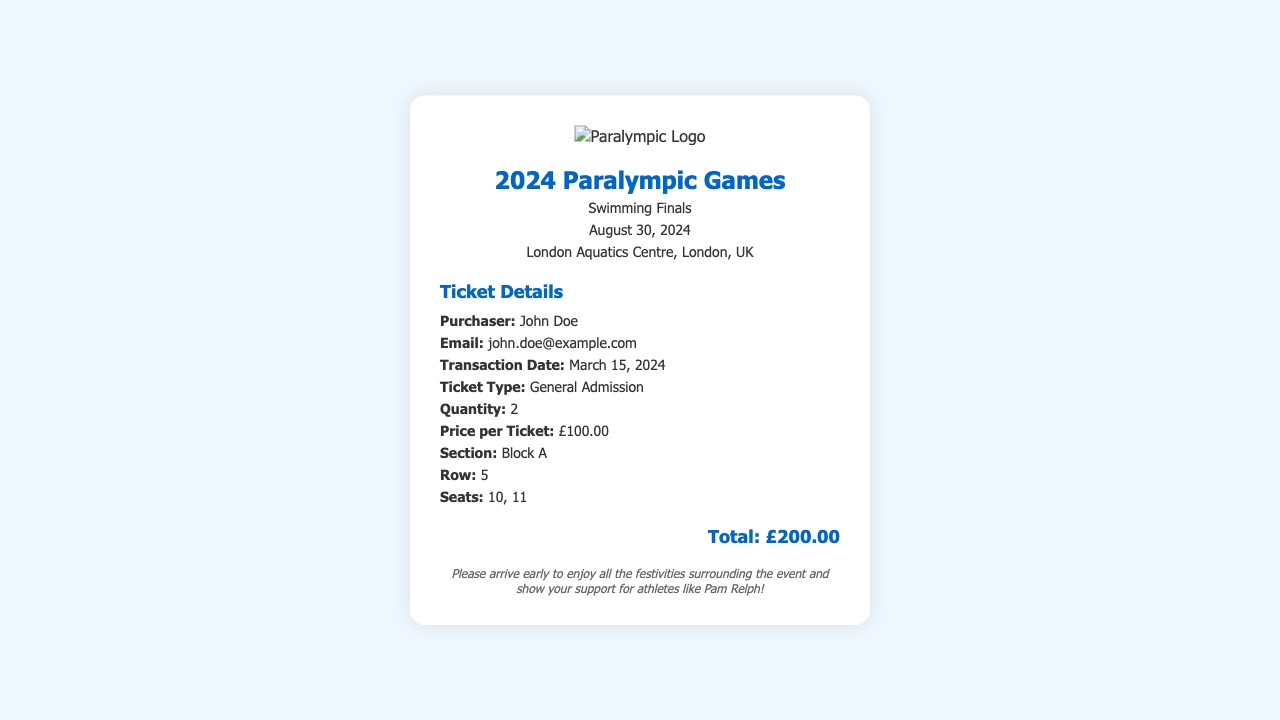What type of event are the tickets for? The tickets are for the Swimming Finals event in the 2024 Paralympic Games.
Answer: Swimming Finals What is the total cost of the tickets? The total cost of the tickets is stated at the bottom of the receipt.
Answer: £200.00 How many tickets were purchased? The quantity of tickets purchased is mentioned in the ticket details section.
Answer: 2 What is the date of the event? The date of the event is clearly indicated in the header section of the receipt.
Answer: August 30, 2024 What section are the seats located in? The section of the seats is specified in the ticket details.
Answer: Block A Who is the purchaser of the tickets? The purchaser's name is provided in the details section of the receipt.
Answer: John Doe What is the price per ticket? The price per ticket is listed in the ticket details section.
Answer: £100.00 What is the email address of the purchaser? The email of the purchaser can be found in the details section of the receipt.
Answer: john.doe@example.com What is the seating arrangement? The specific seats are outlined in the ticket details under "Seats."
Answer: 10, 11 